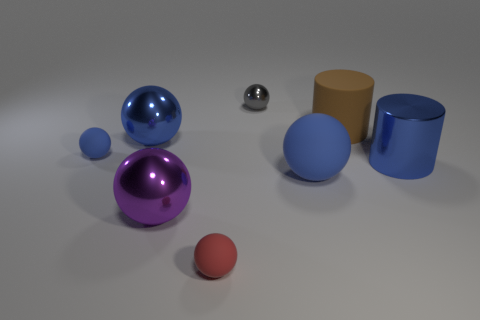What size is the red object that is the same shape as the purple metal thing?
Provide a succinct answer. Small. Is the number of large cylinders on the right side of the blue metallic cylinder less than the number of tiny rubber balls?
Your response must be concise. Yes. Are there any other things that have the same shape as the tiny gray metal object?
Your answer should be very brief. Yes. There is another thing that is the same shape as the brown matte object; what color is it?
Provide a succinct answer. Blue. Do the matte ball in front of the purple metallic thing and the purple thing have the same size?
Ensure brevity in your answer.  No. There is a metallic ball that is to the right of the tiny matte thing that is in front of the purple metallic object; what is its size?
Offer a terse response. Small. Is the tiny red thing made of the same material as the large blue object behind the large blue metallic cylinder?
Offer a very short reply. No. Is the number of tiny gray balls left of the tiny red rubber object less than the number of blue metallic spheres that are behind the metallic cylinder?
Your response must be concise. Yes. What is the color of the tiny object that is made of the same material as the red ball?
Provide a succinct answer. Blue. There is a tiny sphere in front of the tiny blue thing; is there a brown cylinder that is left of it?
Ensure brevity in your answer.  No. 